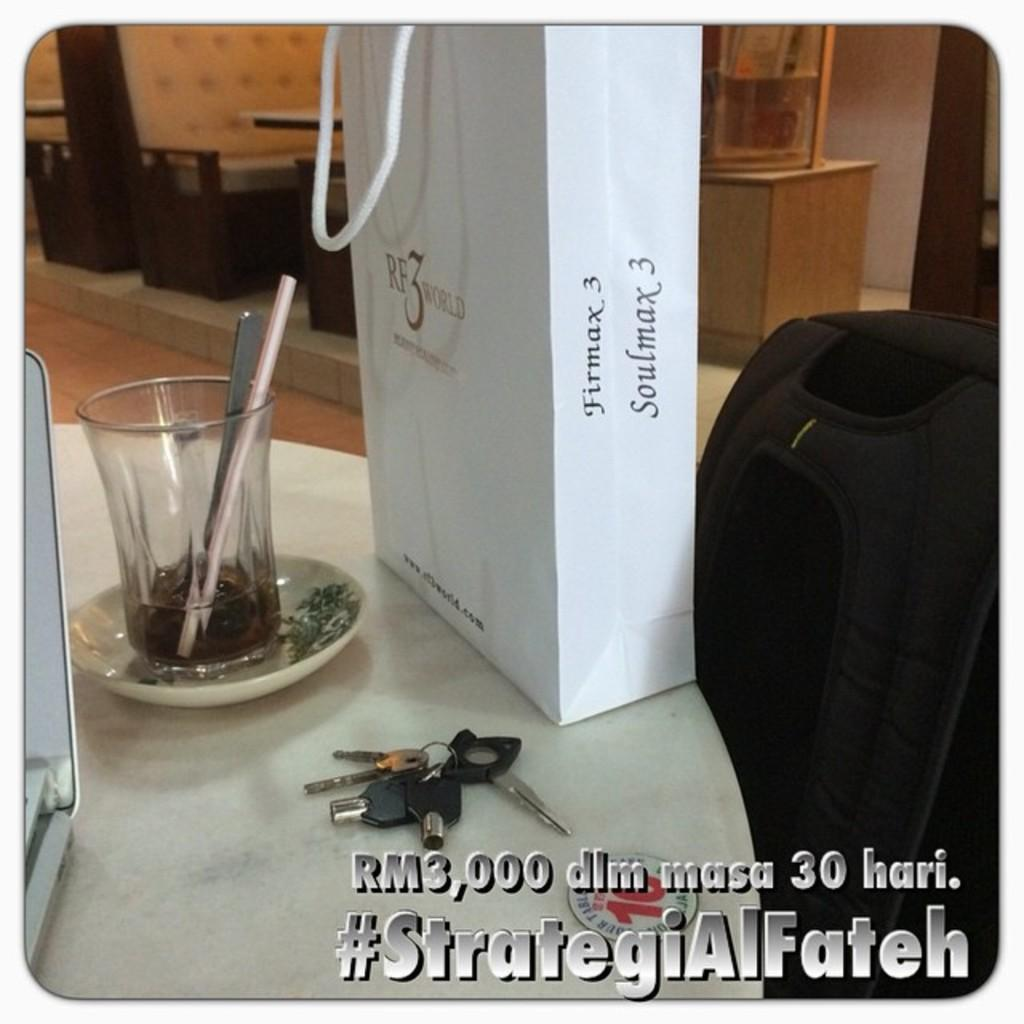<image>
Offer a succinct explanation of the picture presented. A gift bag that says Firmax 3  Soulmax 3 on it. 